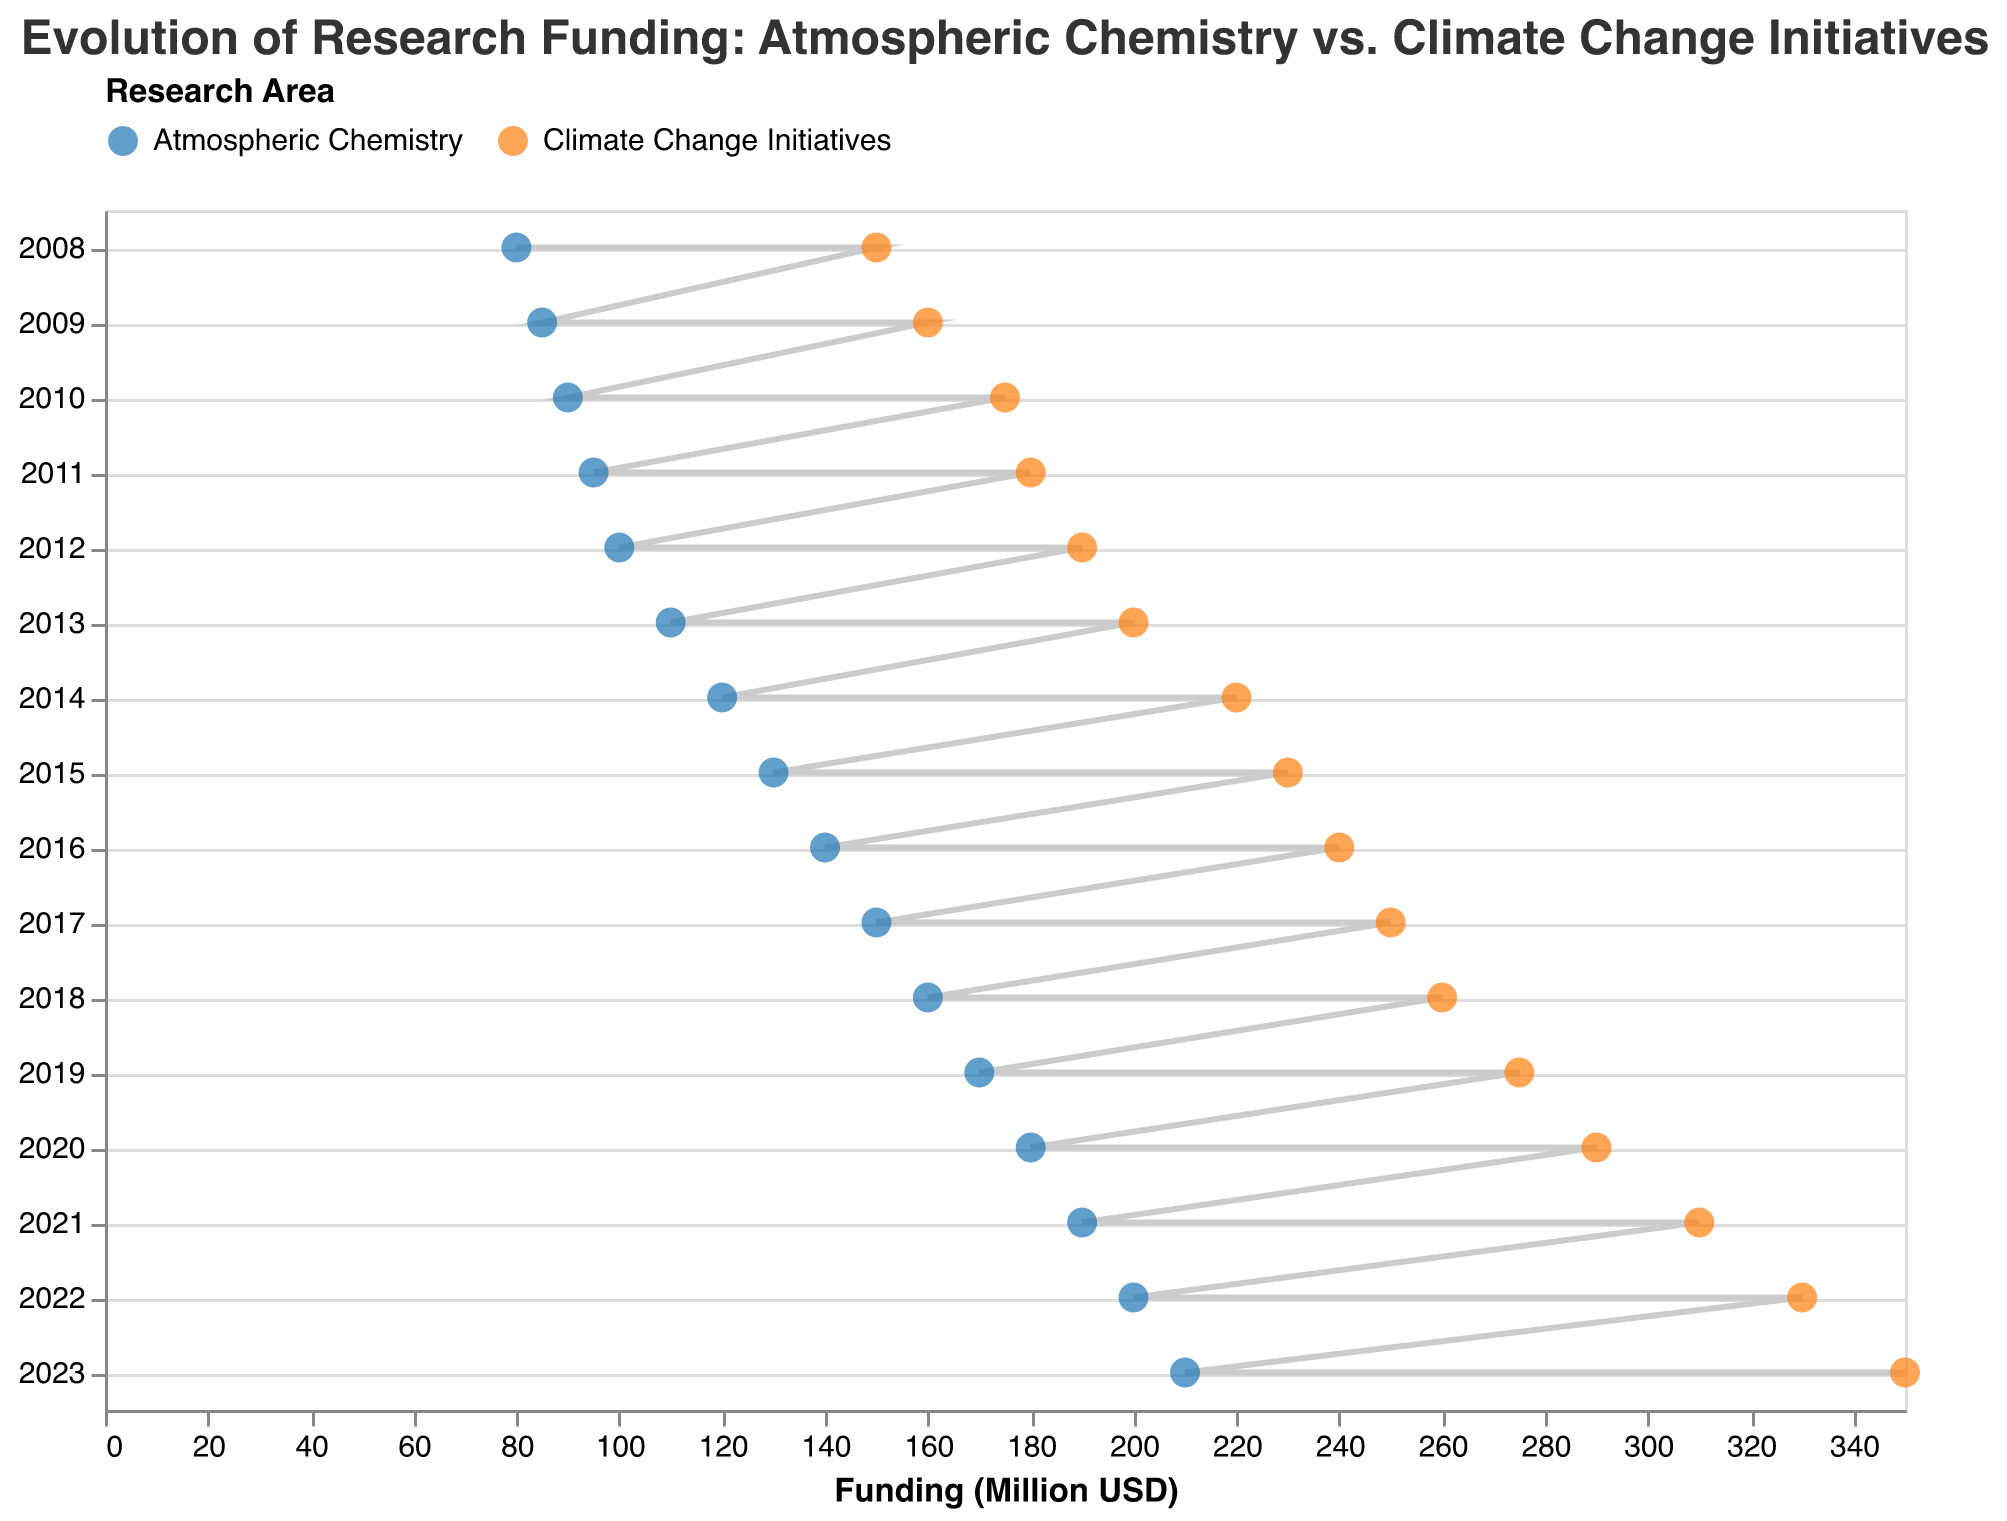What is the title of the plot? The title is usually placed at the top of the plot and describes what the plot represents. In this case, it is "Evolution of Research Funding: Atmospheric Chemistry vs. Climate Change Initiatives."
Answer: Evolution of Research Funding: Atmospheric Chemistry vs. Climate Change Initiatives What do the colors blue and orange represent in the plot? The legend placed at the top of the plot shows that the blue color represents "Atmospheric Chemistry," and the orange color represents "Climate Change Initiatives."
Answer: Blue: Atmospheric Chemistry, Orange: Climate Change Initiatives How did the funding for Climate Change Initiatives compare to Atmospheric Chemistry in 2023? To answer this, locate 2023 on the y-axis, find both data points (blue and orange) on the x-axis, and observe their respective funding values. Climate Change Initiatives had $350 million, while Atmospheric Chemistry had $210 million. So, Climate Change Initiatives had more funding.
Answer: Climate Change Initiatives had more funding What was the total funding in 2020 for both research areas combined? Look at the funding values for Atmospheric Chemistry and Climate Change Initiatives for the year 2020, which are $180 million and $290 million, respectively. Adding these amounts results in $470 million.
Answer: $470 million During what year did Atmospheric Chemistry funding first reach or exceed $100 million? Scan the plot from the bottom upwards for the blue data points until reaching the funding value of at least $100 million. This first happens in 2012.
Answer: 2012 By what amount did funding for Climate Change Initiatives increase between 2014 and 2015? Find the funding values for Climate Change Initiatives in 2014 and 2015, which are $220 million and $230 million, respectively. The difference is $230 million - $220 million = $10 million.
Answer: $10 million In which year was the funding difference between the two research areas the greatest? To find the greatest difference, look at each year's funding values for both areas and compute the differences. The year with the greatest difference is when Climate Change Initiatives had $350 million and Atmospheric Chemistry had $210 million in 2023, a difference of $140 million.
Answer: 2023 What is the average annual increase in funding for Atmospheric Chemistry from 2008 to 2023? Calculate the total increase in funding from 2008 ($80 million) to 2023 ($210 million), giving $210 million - $80 million = $130 million. The number of years is 2023 - 2008 = 15. Divide the total increase by the number of years: $130 million / 15 ≈ $8.67 million per year.
Answer: $8.67 million per year Is there a year when the funding for Atmospheric Chemistry decreased compared to the previous year? Scan through the blue data points across the years and compare the funding values year-over-year. No year shows a decrease; instead, there is a consistent increase.
Answer: No Which research area had a higher growth rate in funding between 2008 and 2023? Calculate the total increase for each area from 2008 to 2023: Atmospheric Chemistry increased from $80 million to $210 million, a difference of $130 million. Climate Change Initiatives increased from $150 million to $350 million, a difference of $200 million. Since Climate Change Initiatives had a larger total increase, it had a higher growth rate in funding.
Answer: Climate Change Initiatives 